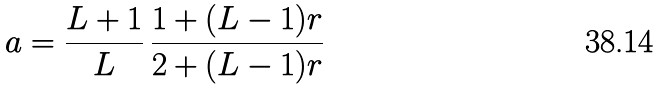Convert formula to latex. <formula><loc_0><loc_0><loc_500><loc_500>a = \frac { L + 1 } { L } \, \frac { 1 + ( L - 1 ) r } { 2 + ( L - 1 ) r }</formula> 